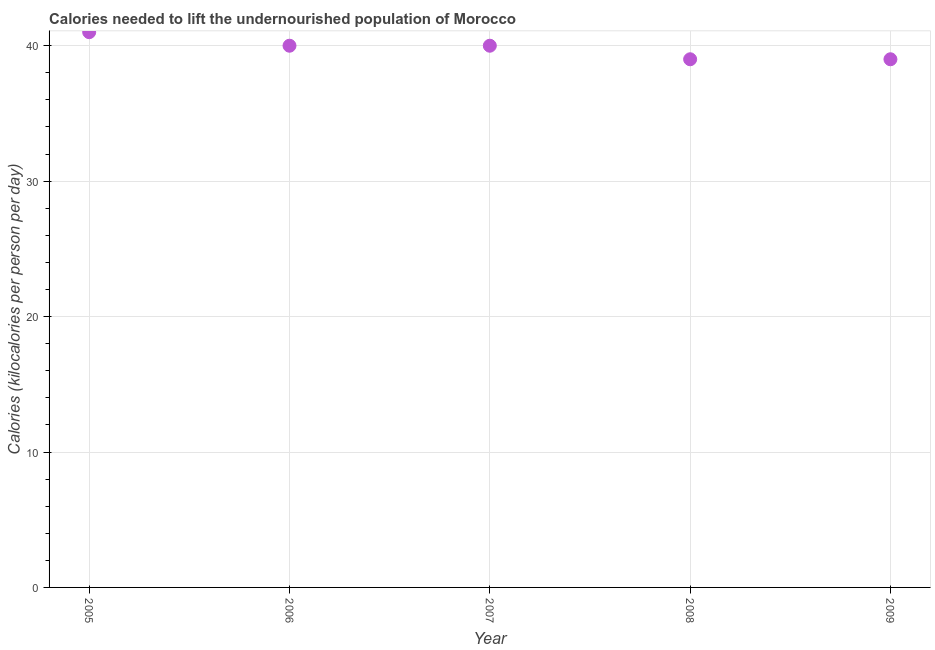What is the depth of food deficit in 2006?
Give a very brief answer. 40. Across all years, what is the maximum depth of food deficit?
Offer a very short reply. 41. Across all years, what is the minimum depth of food deficit?
Ensure brevity in your answer.  39. What is the sum of the depth of food deficit?
Your answer should be compact. 199. What is the difference between the depth of food deficit in 2005 and 2009?
Ensure brevity in your answer.  2. What is the average depth of food deficit per year?
Your answer should be compact. 39.8. In how many years, is the depth of food deficit greater than 6 kilocalories?
Ensure brevity in your answer.  5. Do a majority of the years between 2006 and 2008 (inclusive) have depth of food deficit greater than 22 kilocalories?
Offer a terse response. Yes. What is the ratio of the depth of food deficit in 2005 to that in 2009?
Offer a terse response. 1.05. Is the difference between the depth of food deficit in 2008 and 2009 greater than the difference between any two years?
Give a very brief answer. No. What is the difference between the highest and the lowest depth of food deficit?
Keep it short and to the point. 2. Does the depth of food deficit monotonically increase over the years?
Keep it short and to the point. No. What is the difference between two consecutive major ticks on the Y-axis?
Keep it short and to the point. 10. What is the title of the graph?
Your response must be concise. Calories needed to lift the undernourished population of Morocco. What is the label or title of the X-axis?
Provide a succinct answer. Year. What is the label or title of the Y-axis?
Offer a very short reply. Calories (kilocalories per person per day). What is the Calories (kilocalories per person per day) in 2006?
Keep it short and to the point. 40. What is the Calories (kilocalories per person per day) in 2008?
Your response must be concise. 39. What is the difference between the Calories (kilocalories per person per day) in 2005 and 2006?
Make the answer very short. 1. What is the difference between the Calories (kilocalories per person per day) in 2006 and 2007?
Your response must be concise. 0. What is the difference between the Calories (kilocalories per person per day) in 2007 and 2008?
Provide a short and direct response. 1. What is the ratio of the Calories (kilocalories per person per day) in 2005 to that in 2007?
Offer a terse response. 1.02. What is the ratio of the Calories (kilocalories per person per day) in 2005 to that in 2008?
Your answer should be very brief. 1.05. What is the ratio of the Calories (kilocalories per person per day) in 2005 to that in 2009?
Make the answer very short. 1.05. What is the ratio of the Calories (kilocalories per person per day) in 2006 to that in 2008?
Ensure brevity in your answer.  1.03. What is the ratio of the Calories (kilocalories per person per day) in 2006 to that in 2009?
Your response must be concise. 1.03. What is the ratio of the Calories (kilocalories per person per day) in 2007 to that in 2009?
Your response must be concise. 1.03. What is the ratio of the Calories (kilocalories per person per day) in 2008 to that in 2009?
Make the answer very short. 1. 